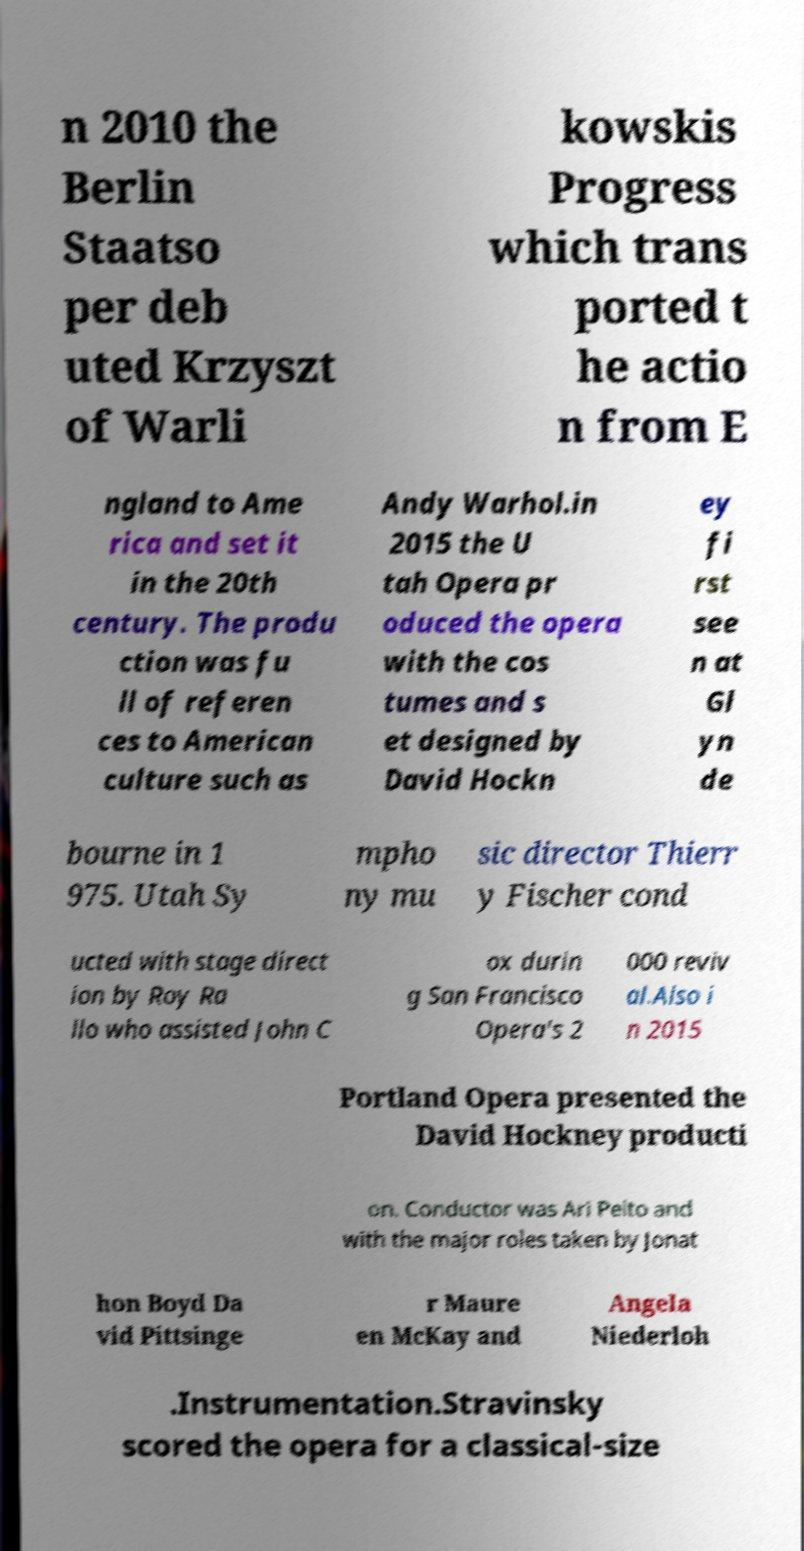For documentation purposes, I need the text within this image transcribed. Could you provide that? n 2010 the Berlin Staatso per deb uted Krzyszt of Warli kowskis Progress which trans ported t he actio n from E ngland to Ame rica and set it in the 20th century. The produ ction was fu ll of referen ces to American culture such as Andy Warhol.in 2015 the U tah Opera pr oduced the opera with the cos tumes and s et designed by David Hockn ey fi rst see n at Gl yn de bourne in 1 975. Utah Sy mpho ny mu sic director Thierr y Fischer cond ucted with stage direct ion by Roy Ra llo who assisted John C ox durin g San Francisco Opera's 2 000 reviv al.Also i n 2015 Portland Opera presented the David Hockney producti on. Conductor was Ari Pelto and with the major roles taken by Jonat hon Boyd Da vid Pittsinge r Maure en McKay and Angela Niederloh .Instrumentation.Stravinsky scored the opera for a classical-size 